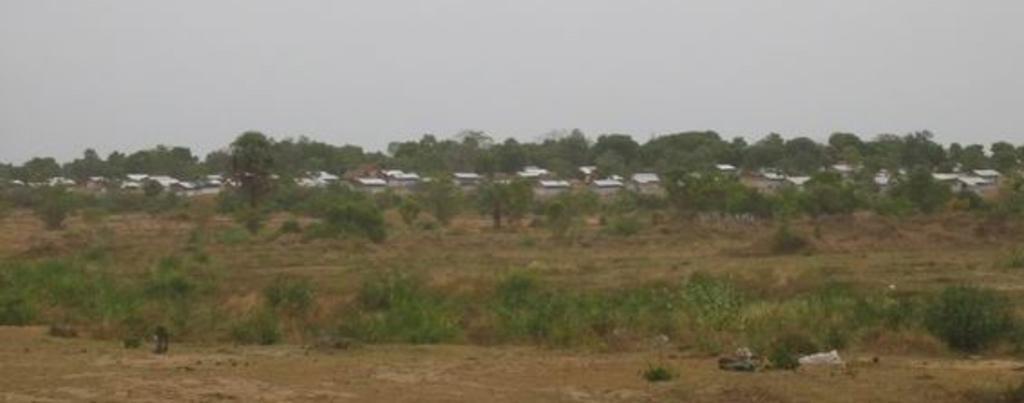Could you give a brief overview of what you see in this image? In the image there is a land covered with some dry grass and plants, behind the land there are few houses and around the houses there are many trees. 